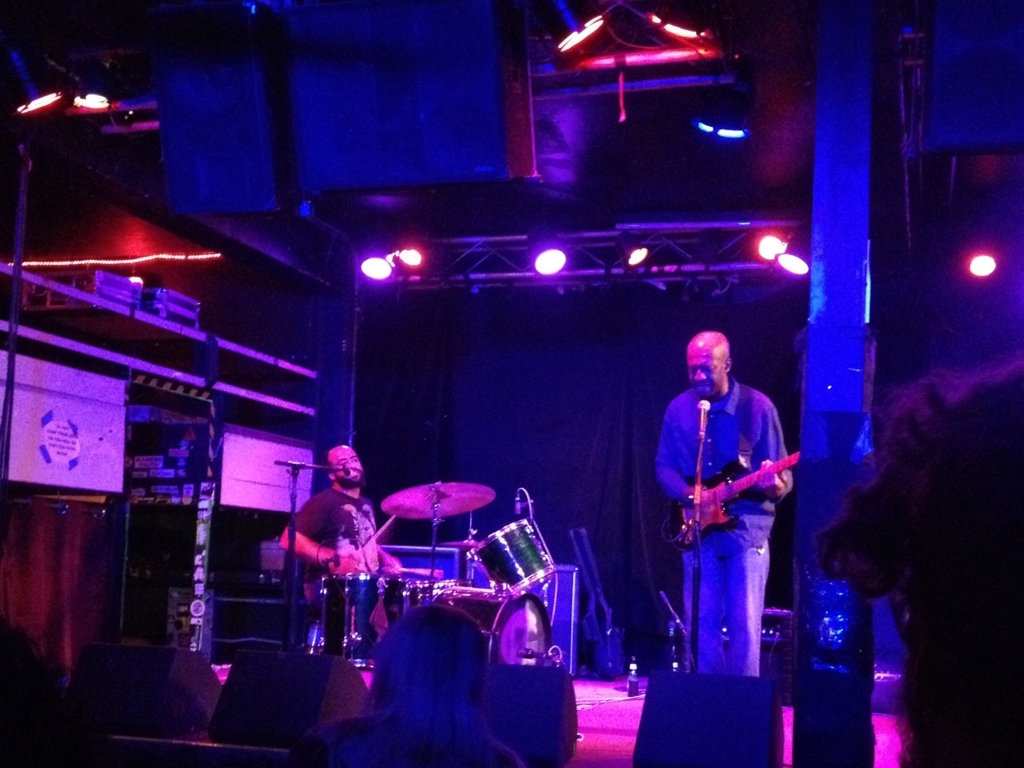Can you describe the mood of this live music performance based on the lighting and the musicians' expressions? The illumination in the image casts a warm and intimate glow on the scene, suggestive of a cozy live music setting. The musician in the foreground seems deeply engrossed in the performance, which can indicate a soulful and passionate atmosphere. The dimly lit venue and the concentrated expressions of the performers imply a serious but inviting musical experience. 